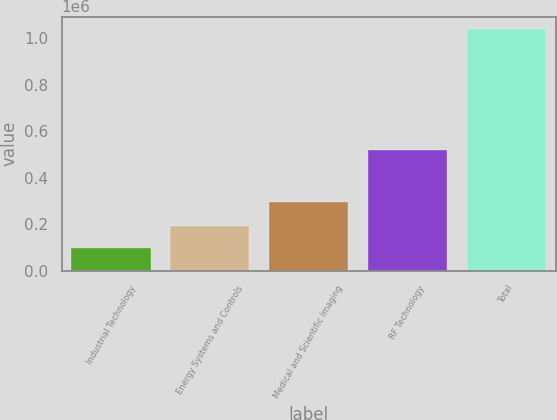Convert chart. <chart><loc_0><loc_0><loc_500><loc_500><bar_chart><fcel>Industrial Technology<fcel>Energy Systems and Controls<fcel>Medical and Scientific Imaging<fcel>RF Technology<fcel>Total<nl><fcel>97507<fcel>191873<fcel>296098<fcel>520727<fcel>1.04117e+06<nl></chart> 